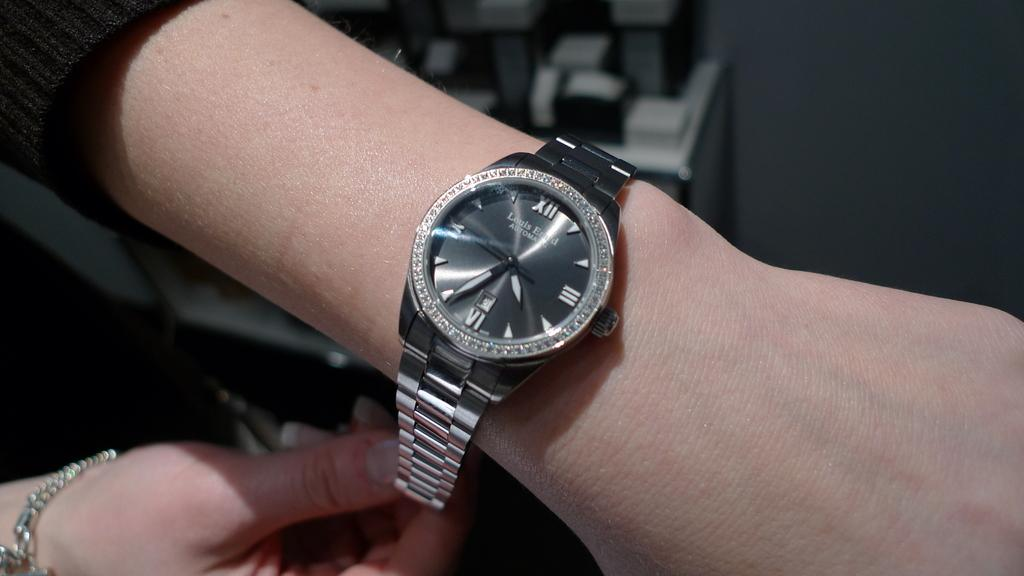<image>
Relay a brief, clear account of the picture shown. A person is wearing a silver Louis Erard wrist watch that shows the time as 4:34. 